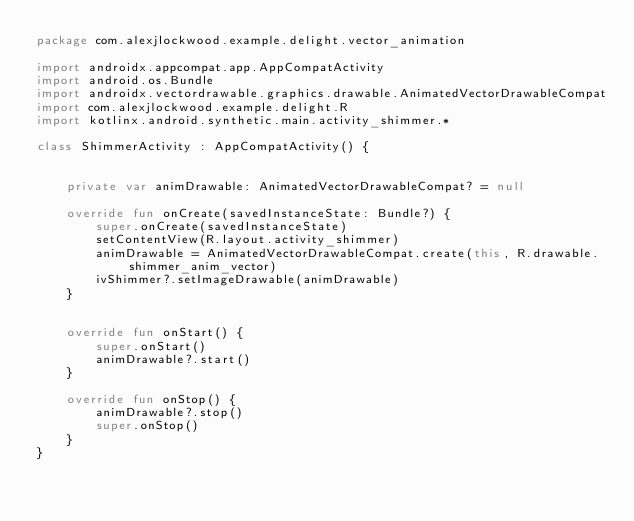<code> <loc_0><loc_0><loc_500><loc_500><_Kotlin_>package com.alexjlockwood.example.delight.vector_animation

import androidx.appcompat.app.AppCompatActivity
import android.os.Bundle
import androidx.vectordrawable.graphics.drawable.AnimatedVectorDrawableCompat
import com.alexjlockwood.example.delight.R
import kotlinx.android.synthetic.main.activity_shimmer.*

class ShimmerActivity : AppCompatActivity() {


    private var animDrawable: AnimatedVectorDrawableCompat? = null

    override fun onCreate(savedInstanceState: Bundle?) {
        super.onCreate(savedInstanceState)
        setContentView(R.layout.activity_shimmer)
        animDrawable = AnimatedVectorDrawableCompat.create(this, R.drawable.shimmer_anim_vector)
        ivShimmer?.setImageDrawable(animDrawable)
    }


    override fun onStart() {
        super.onStart()
        animDrawable?.start()
    }

    override fun onStop() {
        animDrawable?.stop()
        super.onStop()
    }
}</code> 